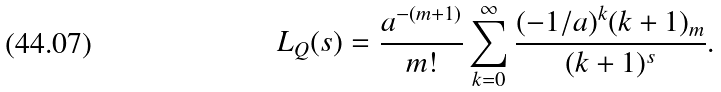Convert formula to latex. <formula><loc_0><loc_0><loc_500><loc_500>L _ { Q } ( s ) = \frac { a ^ { - ( m + 1 ) } } { m ! } \sum _ { k = 0 } ^ { \infty } \frac { ( - 1 / a ) ^ { k } ( k + 1 ) _ { m } } { ( k + 1 ) ^ { s } } .</formula> 